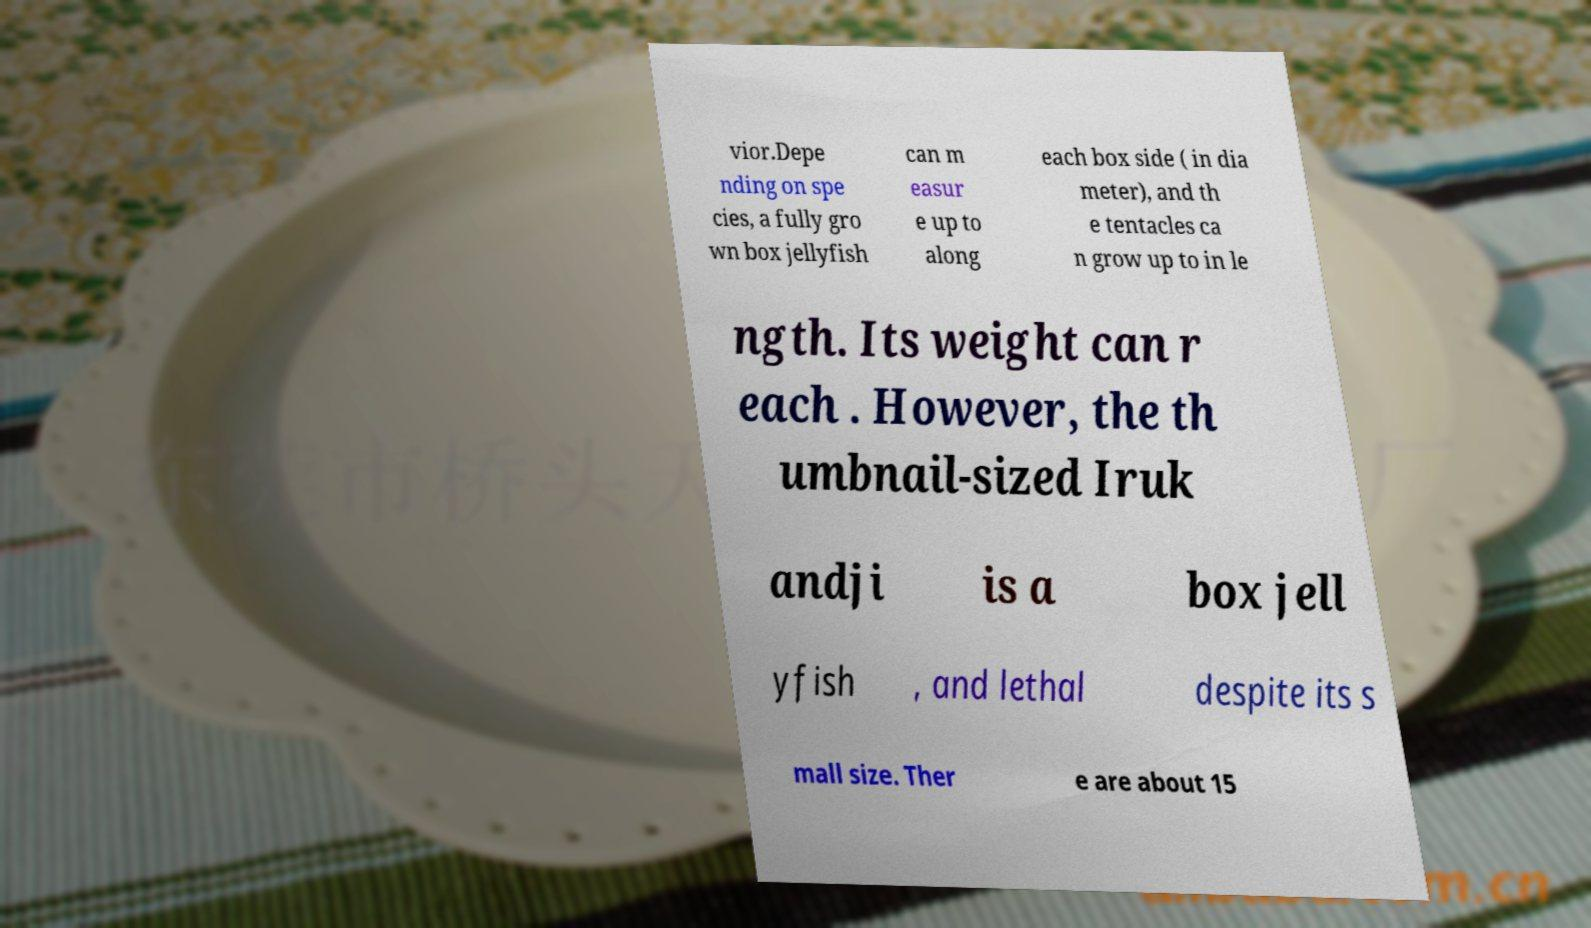For documentation purposes, I need the text within this image transcribed. Could you provide that? vior.Depe nding on spe cies, a fully gro wn box jellyfish can m easur e up to along each box side ( in dia meter), and th e tentacles ca n grow up to in le ngth. Its weight can r each . However, the th umbnail-sized Iruk andji is a box jell yfish , and lethal despite its s mall size. Ther e are about 15 